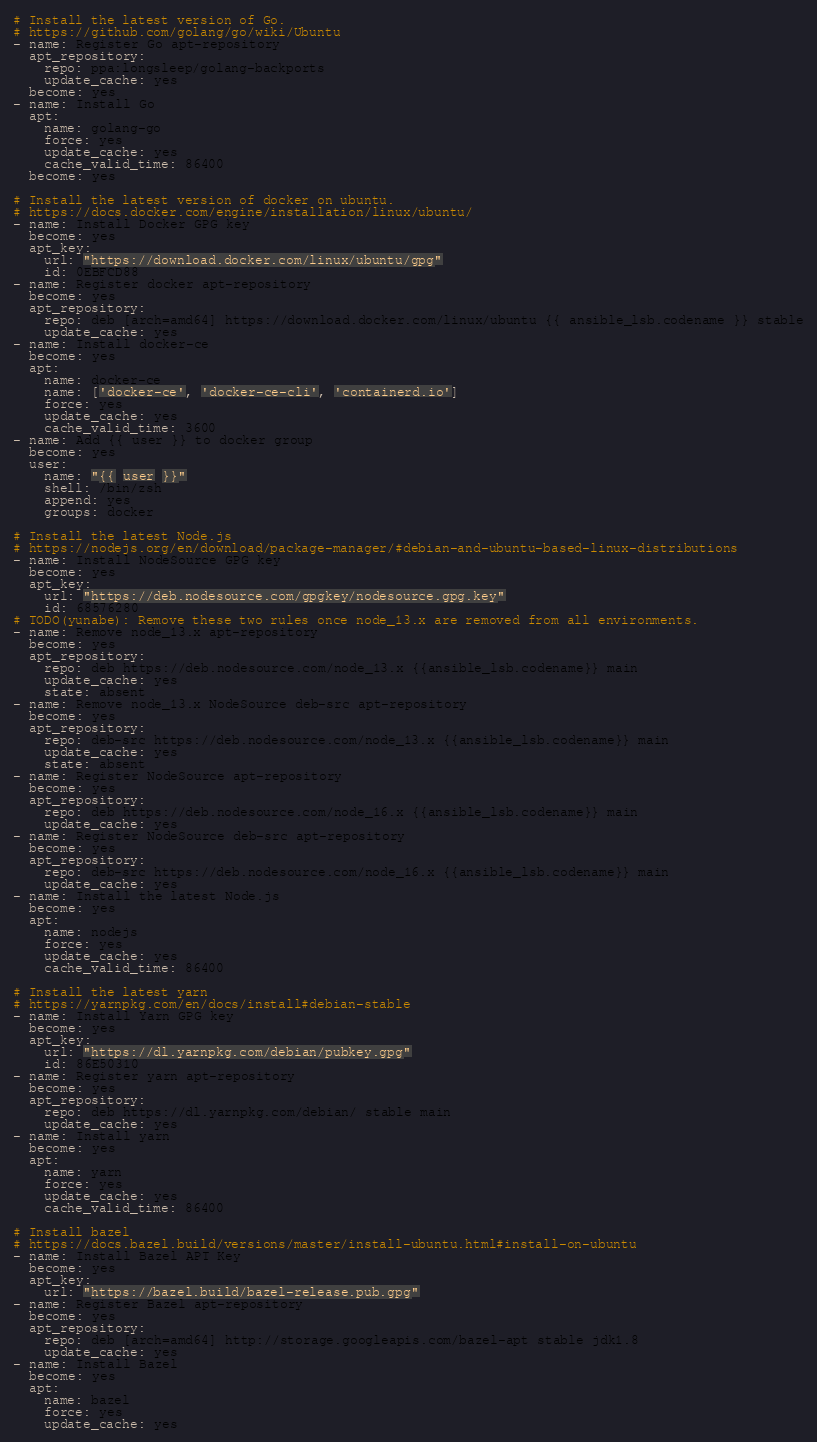<code> <loc_0><loc_0><loc_500><loc_500><_YAML_># Install the latest version of Go.
# https://github.com/golang/go/wiki/Ubuntu
- name: Register Go apt-repository
  apt_repository:
    repo: ppa:longsleep/golang-backports
    update_cache: yes
  become: yes
- name: Install Go
  apt:
    name: golang-go
    force: yes
    update_cache: yes
    cache_valid_time: 86400
  become: yes

# Install the latest version of docker on ubuntu.
# https://docs.docker.com/engine/installation/linux/ubuntu/
- name: Install Docker GPG key
  become: yes
  apt_key:
    url: "https://download.docker.com/linux/ubuntu/gpg"
    id: 0EBFCD88
- name: Register docker apt-repository
  become: yes
  apt_repository:
    repo: deb [arch=amd64] https://download.docker.com/linux/ubuntu {{ ansible_lsb.codename }} stable
    update_cache: yes
- name: Install docker-ce
  become: yes
  apt:
    name: docker-ce
    name: ['docker-ce', 'docker-ce-cli', 'containerd.io']
    force: yes
    update_cache: yes
    cache_valid_time: 3600
- name: Add {{ user }} to docker group
  become: yes
  user:
    name: "{{ user }}"
    shell: /bin/zsh
    append: yes
    groups: docker

# Install the latest Node.js
# https://nodejs.org/en/download/package-manager/#debian-and-ubuntu-based-linux-distributions
- name: Install NodeSource GPG key
  become: yes
  apt_key:
    url: "https://deb.nodesource.com/gpgkey/nodesource.gpg.key"
    id: 68576280
# TODO(yunabe): Remove these two rules once node_13.x are removed from all environments.
- name: Remove node_13.x apt-repository
  become: yes
  apt_repository:
    repo: deb https://deb.nodesource.com/node_13.x {{ansible_lsb.codename}} main
    update_cache: yes
    state: absent
- name: Remove node_13.x NodeSource deb-src apt-repository
  become: yes
  apt_repository:
    repo: deb-src https://deb.nodesource.com/node_13.x {{ansible_lsb.codename}} main
    update_cache: yes
    state: absent
- name: Register NodeSource apt-repository
  become: yes
  apt_repository:
    repo: deb https://deb.nodesource.com/node_16.x {{ansible_lsb.codename}} main
    update_cache: yes
- name: Register NodeSource deb-src apt-repository
  become: yes
  apt_repository:
    repo: deb-src https://deb.nodesource.com/node_16.x {{ansible_lsb.codename}} main
    update_cache: yes
- name: Install the latest Node.js
  become: yes
  apt:
    name: nodejs
    force: yes
    update_cache: yes
    cache_valid_time: 86400

# Install the latest yarn
# https://yarnpkg.com/en/docs/install#debian-stable
- name: Install Yarn GPG key
  become: yes
  apt_key:
    url: "https://dl.yarnpkg.com/debian/pubkey.gpg"
    id: 86E50310
- name: Register yarn apt-repository
  become: yes
  apt_repository:
    repo: deb https://dl.yarnpkg.com/debian/ stable main
    update_cache: yes
- name: Install yarn
  become: yes
  apt:
    name: yarn
    force: yes
    update_cache: yes
    cache_valid_time: 86400

# Install bazel
# https://docs.bazel.build/versions/master/install-ubuntu.html#install-on-ubuntu
- name: Install Bazel APT Key
  become: yes
  apt_key:
    url: "https://bazel.build/bazel-release.pub.gpg"
- name: Register Bazel apt-repository
  become: yes
  apt_repository:
    repo: deb [arch=amd64] http://storage.googleapis.com/bazel-apt stable jdk1.8
    update_cache: yes
- name: Install Bazel
  become: yes
  apt:
    name: bazel
    force: yes
    update_cache: yes</code> 